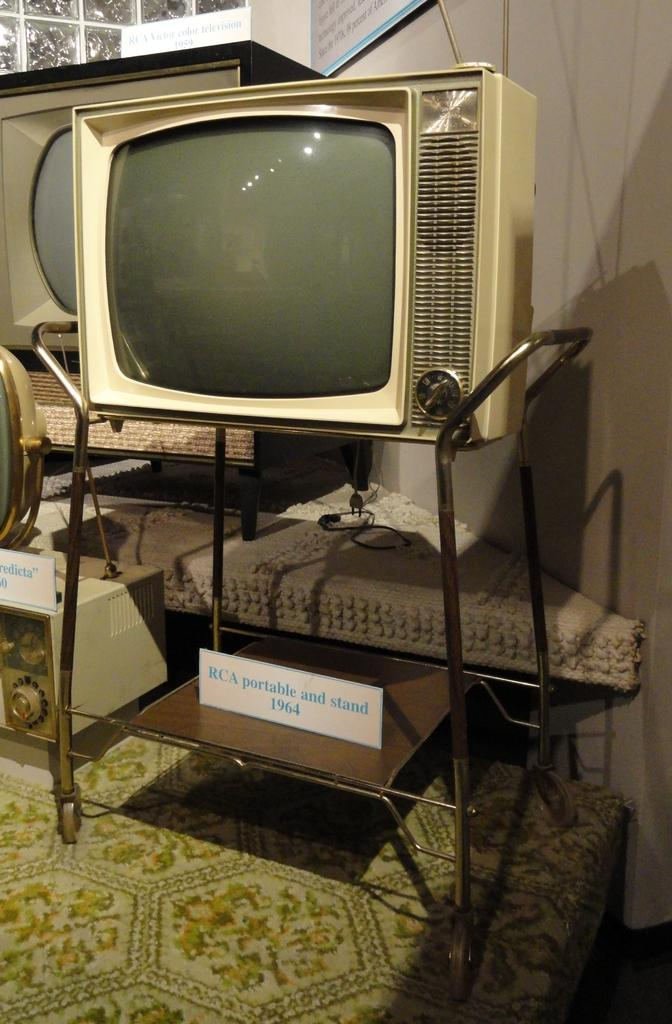<image>
Summarize the visual content of the image. The old tv and display shown here is from 1964. 